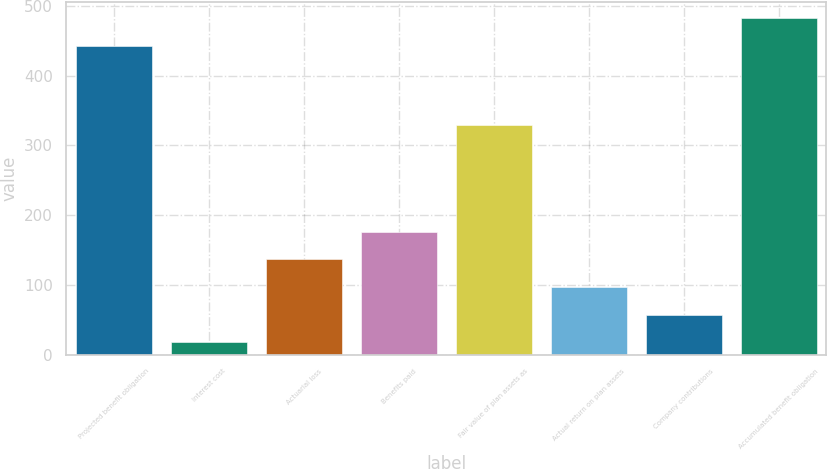Convert chart. <chart><loc_0><loc_0><loc_500><loc_500><bar_chart><fcel>Projected benefit obligation<fcel>Interest cost<fcel>Actuarial loss<fcel>Benefits paid<fcel>Fair value of plan assets as<fcel>Actual return on plan assets<fcel>Company contributions<fcel>Accumulated benefit obligation<nl><fcel>442.55<fcel>17.9<fcel>136.85<fcel>176.5<fcel>329.75<fcel>97.2<fcel>57.55<fcel>482.2<nl></chart> 